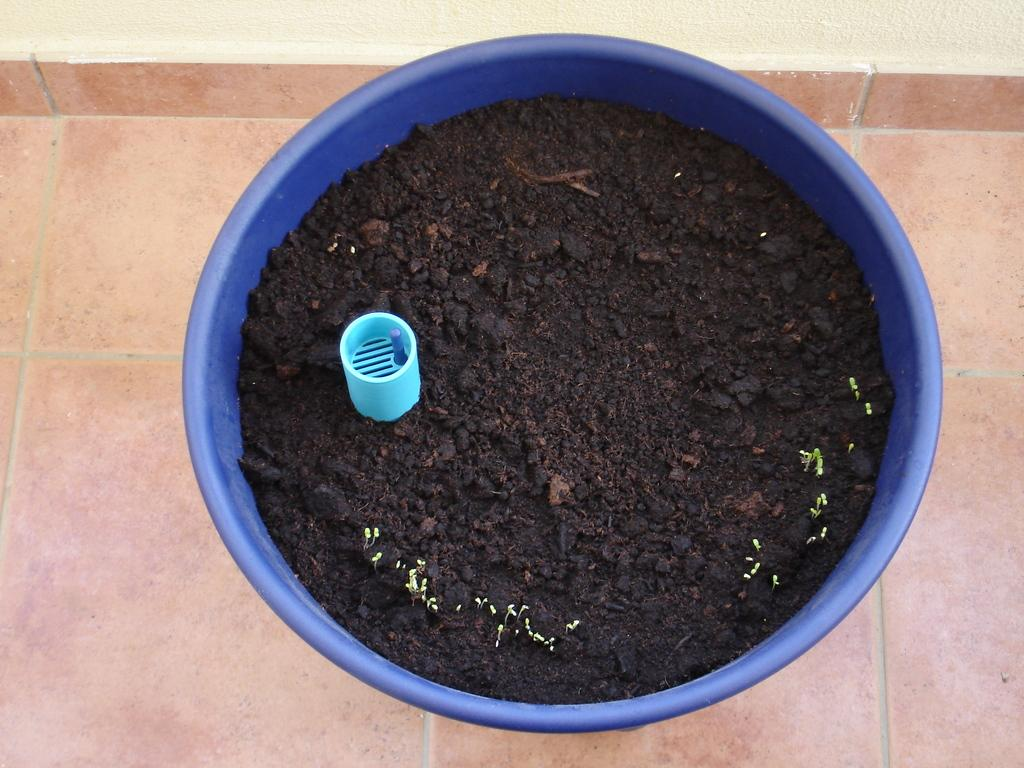What color is the bucket in the image? The bucket in the image is blue. What is inside the blue bucket? The blue bucket contains soil. Can you describe the object inside the blue bucket? There is a blue object in the blue bucket. What type of protest is happening near the blue bucket in the image? There is no protest present in the image; it only features a blue bucket containing soil and a blue object. What kind of oatmeal is being served in the blue bucket? There is no oatmeal present in the image; the blue bucket contains soil and a blue object. 